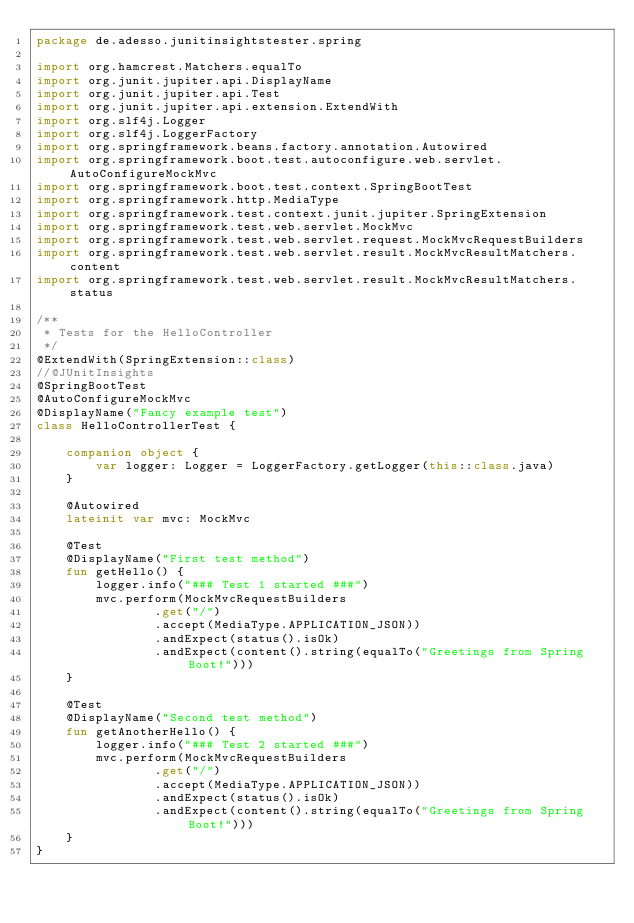<code> <loc_0><loc_0><loc_500><loc_500><_Kotlin_>package de.adesso.junitinsightstester.spring

import org.hamcrest.Matchers.equalTo
import org.junit.jupiter.api.DisplayName
import org.junit.jupiter.api.Test
import org.junit.jupiter.api.extension.ExtendWith
import org.slf4j.Logger
import org.slf4j.LoggerFactory
import org.springframework.beans.factory.annotation.Autowired
import org.springframework.boot.test.autoconfigure.web.servlet.AutoConfigureMockMvc
import org.springframework.boot.test.context.SpringBootTest
import org.springframework.http.MediaType
import org.springframework.test.context.junit.jupiter.SpringExtension
import org.springframework.test.web.servlet.MockMvc
import org.springframework.test.web.servlet.request.MockMvcRequestBuilders
import org.springframework.test.web.servlet.result.MockMvcResultMatchers.content
import org.springframework.test.web.servlet.result.MockMvcResultMatchers.status

/**
 * Tests for the HelloController
 */
@ExtendWith(SpringExtension::class)
//@JUnitInsights
@SpringBootTest
@AutoConfigureMockMvc
@DisplayName("Fancy example test")
class HelloControllerTest {

    companion object {
        var logger: Logger = LoggerFactory.getLogger(this::class.java)
    }

    @Autowired
    lateinit var mvc: MockMvc

    @Test
    @DisplayName("First test method")
    fun getHello() {
        logger.info("### Test 1 started ###")
        mvc.perform(MockMvcRequestBuilders
                .get("/")
                .accept(MediaType.APPLICATION_JSON))
                .andExpect(status().isOk)
                .andExpect(content().string(equalTo("Greetings from Spring Boot!")))
    }

    @Test
    @DisplayName("Second test method")
    fun getAnotherHello() {
        logger.info("### Test 2 started ###")
        mvc.perform(MockMvcRequestBuilders
                .get("/")
                .accept(MediaType.APPLICATION_JSON))
                .andExpect(status().isOk)
                .andExpect(content().string(equalTo("Greetings from Spring Boot!")))
    }
}
</code> 